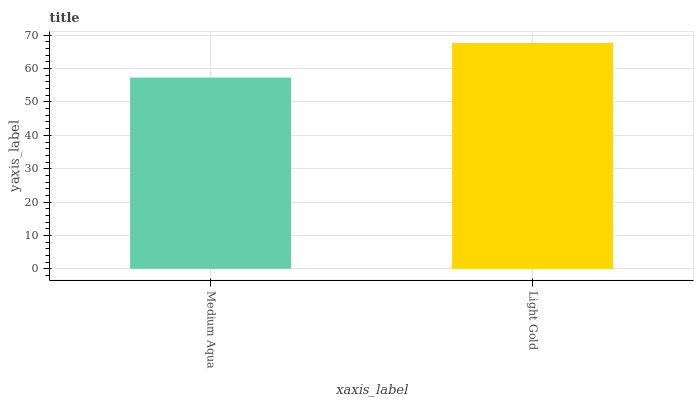Is Medium Aqua the minimum?
Answer yes or no. Yes. Is Light Gold the maximum?
Answer yes or no. Yes. Is Light Gold the minimum?
Answer yes or no. No. Is Light Gold greater than Medium Aqua?
Answer yes or no. Yes. Is Medium Aqua less than Light Gold?
Answer yes or no. Yes. Is Medium Aqua greater than Light Gold?
Answer yes or no. No. Is Light Gold less than Medium Aqua?
Answer yes or no. No. Is Light Gold the high median?
Answer yes or no. Yes. Is Medium Aqua the low median?
Answer yes or no. Yes. Is Medium Aqua the high median?
Answer yes or no. No. Is Light Gold the low median?
Answer yes or no. No. 